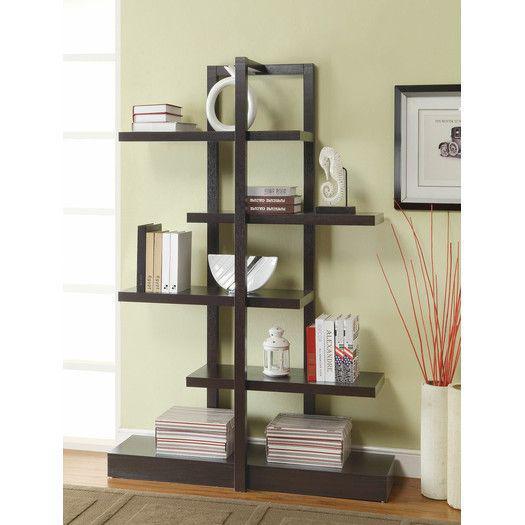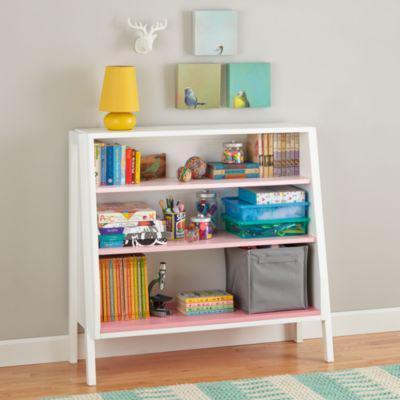The first image is the image on the left, the second image is the image on the right. For the images shown, is this caption "One image shows a shelf unit with open back and sides that resembles a ladder leaning on a wall, and it is not positioned in a corner." true? Answer yes or no. No. The first image is the image on the left, the second image is the image on the right. Given the left and right images, does the statement "In the image on the left, the shelves are placed in a corner." hold true? Answer yes or no. No. 